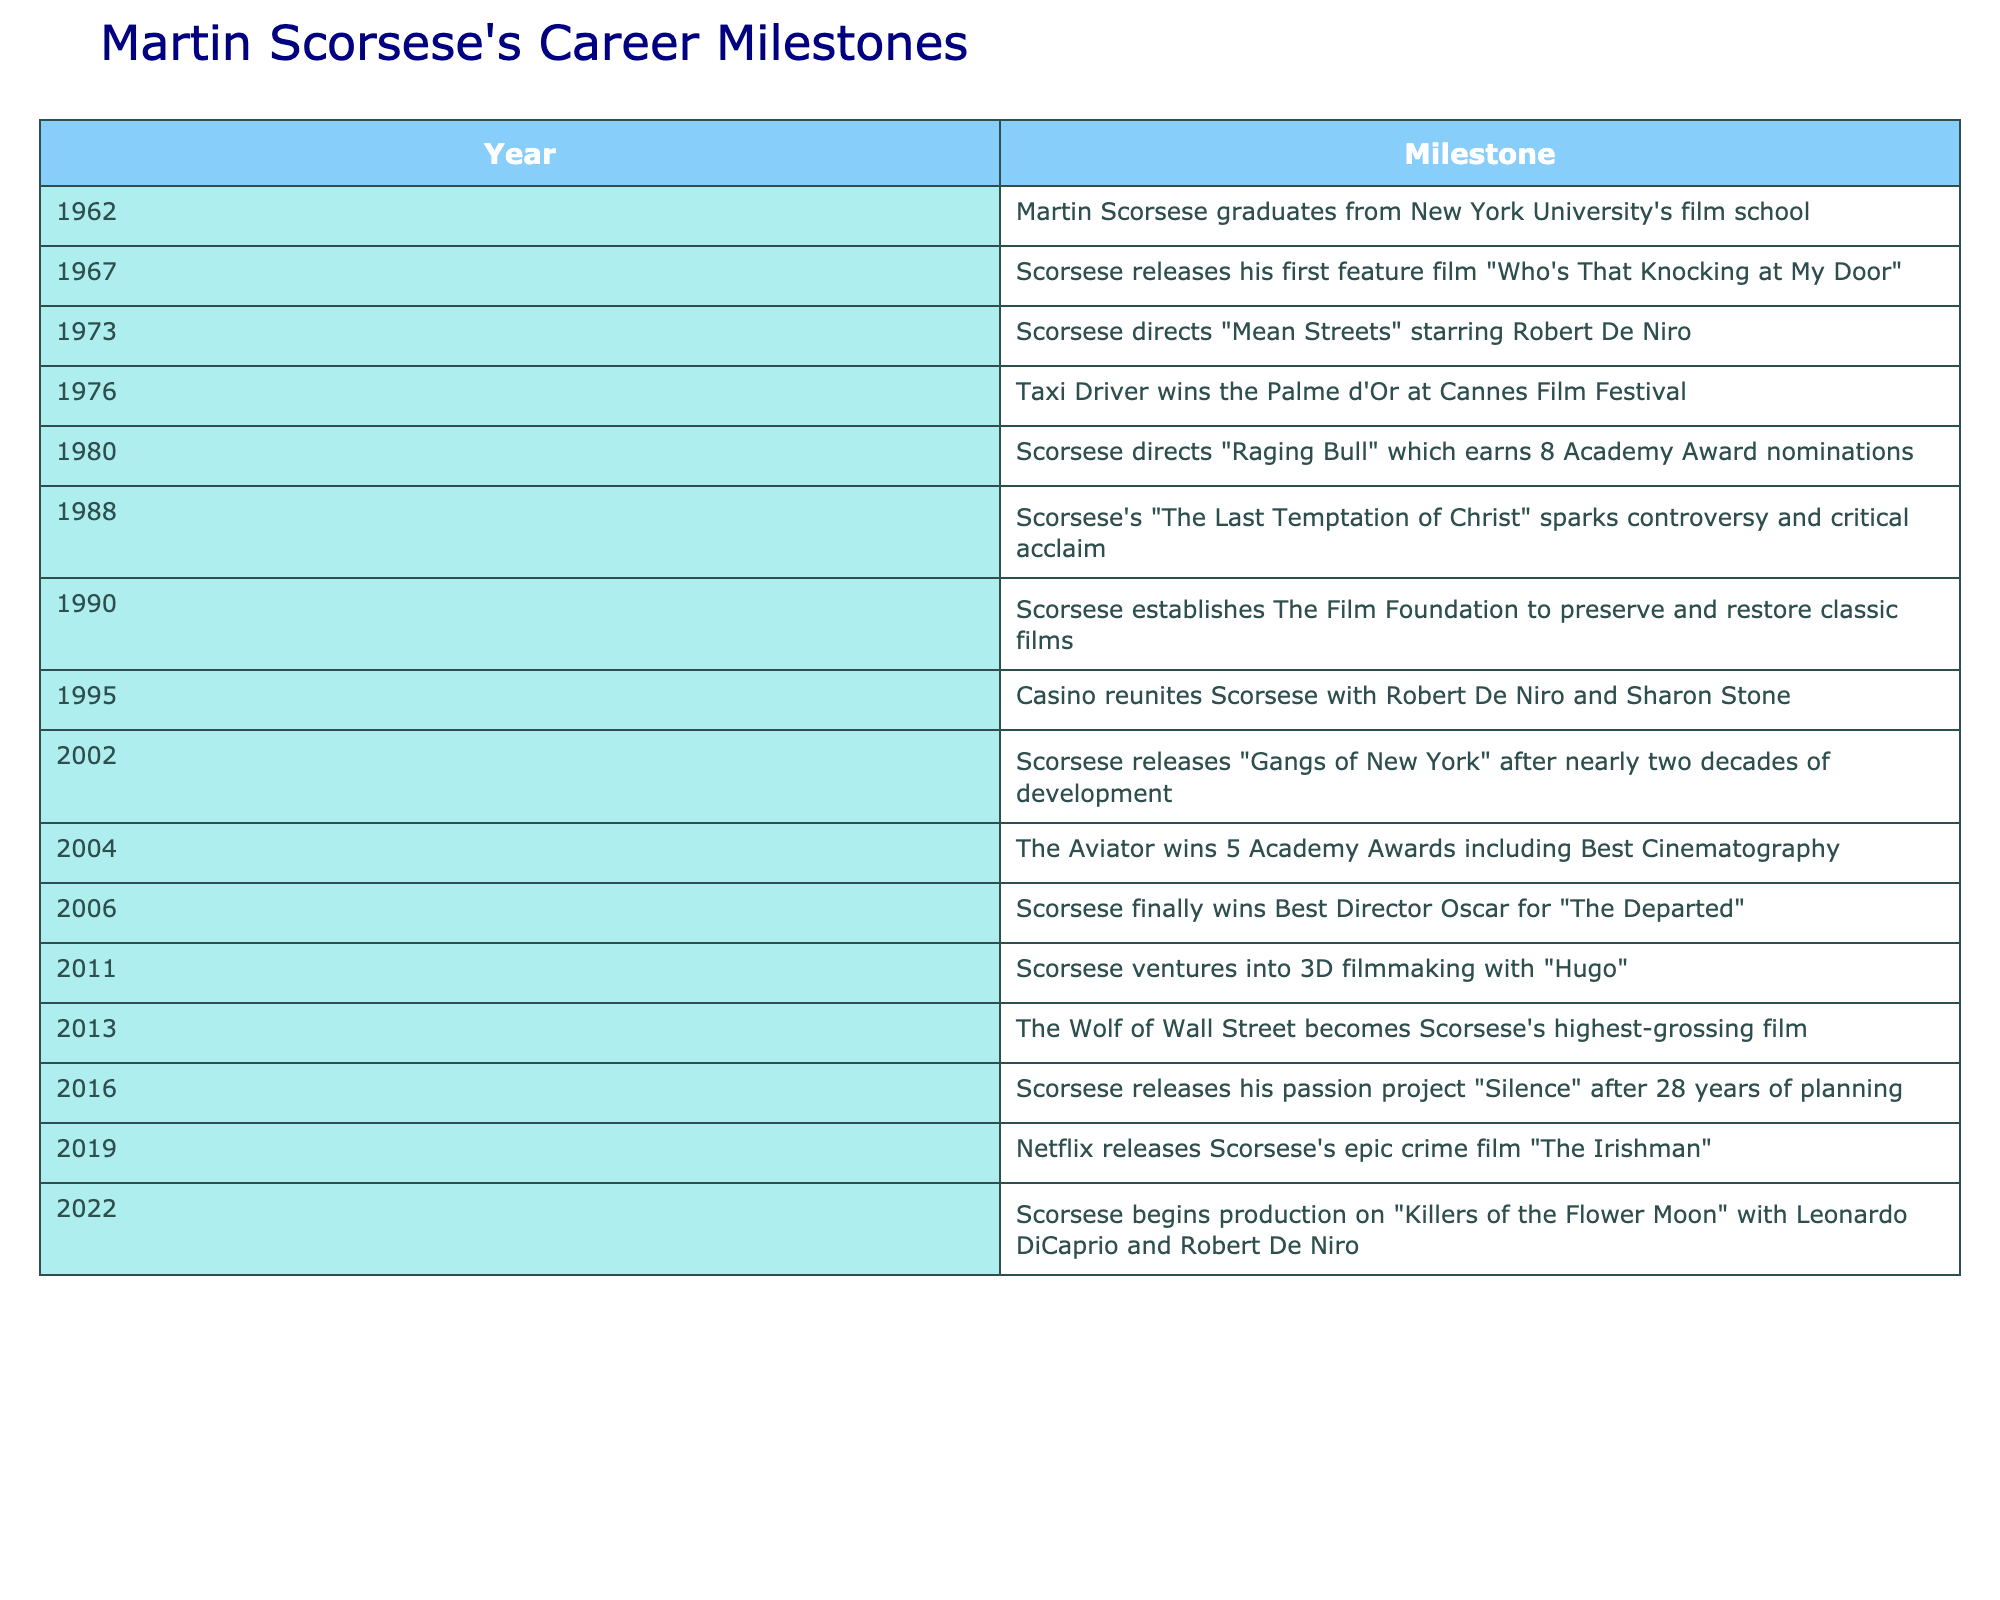What year did Martin Scorsese graduate from film school? According to the table, Martin Scorsese graduated from New York University's film school in 1962.
Answer: 1962 Which film did Scorsese direct that won the Palme d'Or? The table indicates that "Taxi Driver," directed by Scorsese in 1976, won the Palme d'Or at the Cannes Film Festival.
Answer: Taxi Driver Was "Raging Bull" nominated for Academy Awards? The table states that "Raging Bull" earned 8 Academy Award nominations, confirming that it was indeed nominated.
Answer: Yes How many years passed between Scorsese's first feature film and "Taxi Driver"? Scorsese's first feature film was released in 1967 and "Taxi Driver" in 1976. The difference is 1976 - 1967 = 9 years.
Answer: 9 years What was the last film listed in the table that Scorsese directed before "Killers of the Flower Moon"? The last film listed before "Killers of the Flower Moon" is "The Irishman," which was released in 2019.
Answer: The Irishman How many Academy Awards did "The Aviator" win? The table mentions that "The Aviator" won 5 Academy Awards.
Answer: 5 In what year did Scorsese establish The Film Foundation? According to the table, The Film Foundation was established by Scorsese in 1990.
Answer: 1990 Which film became Scorsese's highest-grossing? The table specifies that "The Wolf of Wall Street," released in 2013, became Scorsese's highest-grossing film.
Answer: The Wolf of Wall Street How long did Scorsese work on "Silence" before its release? The table states that "Silence" was released after 28 years of planning. This implies that planning began in 1988 (2016 - 28 = 1988) when he sparked interest in the project, suggesting a long development period.
Answer: 28 years 